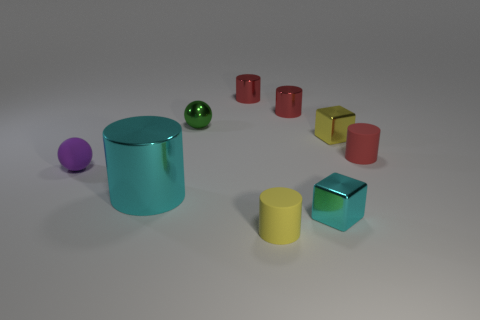Is the size of the purple sphere the same as the cyan cylinder?
Give a very brief answer. No. What number of small objects are either rubber balls or cubes?
Offer a very short reply. 3. What number of yellow objects are behind the green object?
Give a very brief answer. 0. Are there more blocks that are behind the tiny cyan metal block than small green metal cylinders?
Provide a short and direct response. Yes. There is a small yellow thing that is the same material as the tiny cyan block; what shape is it?
Your answer should be compact. Cube. There is a large thing that is to the left of the tiny green metal thing on the left side of the red matte cylinder; what is its color?
Provide a succinct answer. Cyan. Is the small green thing the same shape as the yellow metal object?
Provide a succinct answer. No. There is a small purple thing that is the same shape as the green object; what material is it?
Make the answer very short. Rubber. There is a metal cylinder in front of the small ball in front of the green metal object; is there a small matte thing that is behind it?
Make the answer very short. Yes. Do the tiny purple matte thing and the tiny green thing that is behind the small red matte cylinder have the same shape?
Your response must be concise. Yes. 